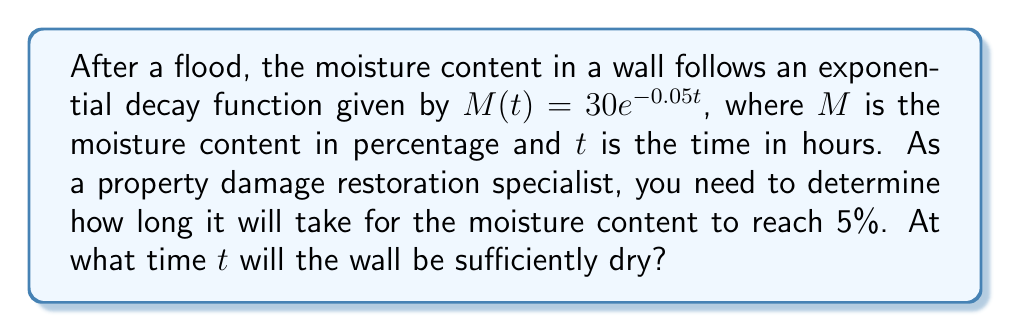Help me with this question. To solve this problem, we need to use the exponential decay function and solve for $t$ when $M(t) = 5$. Let's follow these steps:

1) We start with the given function: $M(t) = 30e^{-0.05t}$

2) We want to find $t$ when $M(t) = 5$, so we set up the equation:
   $5 = 30e^{-0.05t}$

3) Divide both sides by 30:
   $\frac{5}{30} = e^{-0.05t}$

4) Simplify:
   $\frac{1}{6} = e^{-0.05t}$

5) Take the natural logarithm of both sides:
   $\ln(\frac{1}{6}) = \ln(e^{-0.05t})$

6) Simplify the right side using the properties of logarithms:
   $\ln(\frac{1}{6}) = -0.05t$

7) Solve for $t$:
   $t = -\frac{\ln(\frac{1}{6})}{0.05}$

8) Calculate the value:
   $t = -\frac{\ln(0.1666...)}{0.05} \approx 35.67$ hours

Therefore, it will take approximately 35.67 hours for the wall to reach 5% moisture content.
Answer: 35.67 hours 